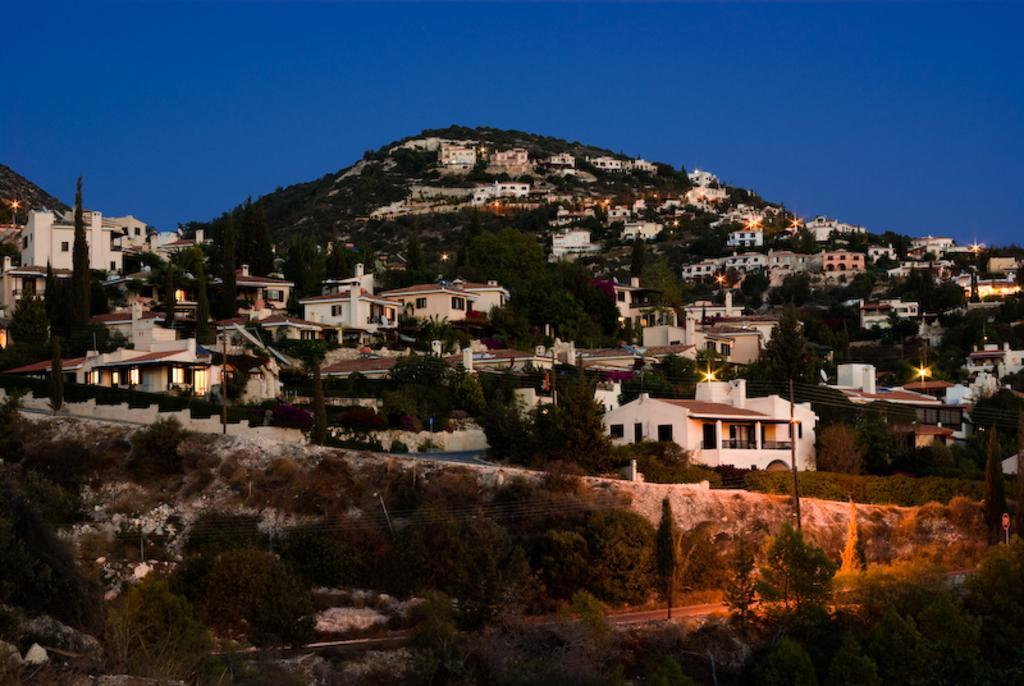How would you summarize this image in a sentence or two? In the foreground of this image, we see a city consisting of buildings, lights, poles, a mountain and the road. On top, we can see the sky. 